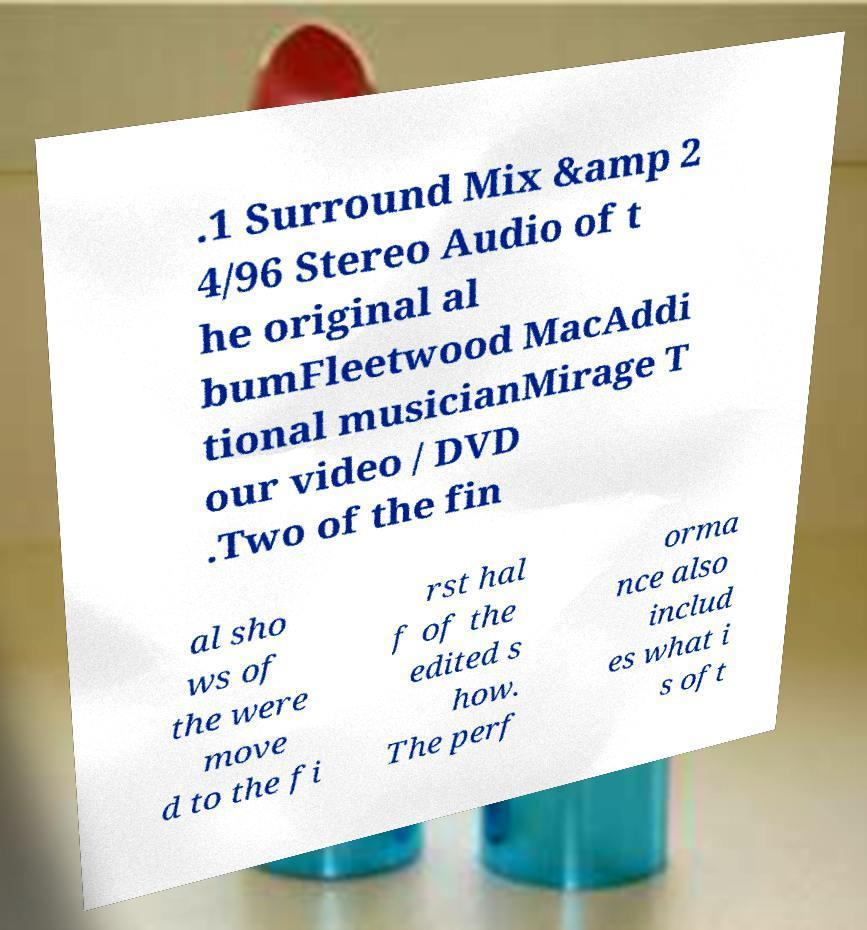Can you read and provide the text displayed in the image?This photo seems to have some interesting text. Can you extract and type it out for me? .1 Surround Mix &amp 2 4/96 Stereo Audio of t he original al bumFleetwood MacAddi tional musicianMirage T our video / DVD .Two of the fin al sho ws of the were move d to the fi rst hal f of the edited s how. The perf orma nce also includ es what i s oft 